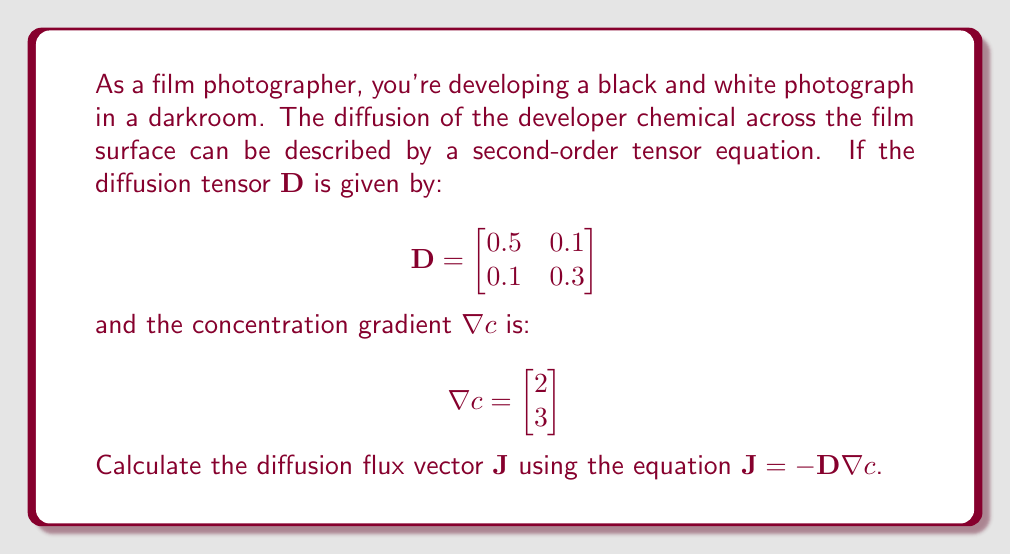Help me with this question. To solve this problem, we need to follow these steps:

1) We are given the diffusion equation: $\mathbf{J} = -\mathbf{D} \nabla c$

2) We have the diffusion tensor $\mathbf{D}$:
   $$\mathbf{D} = \begin{bmatrix}
   0.5 & 0.1 \\
   0.1 & 0.3
   \end{bmatrix}$$

3) And the concentration gradient $\nabla c$:
   $$\nabla c = \begin{bmatrix}
   2 \\
   3
   \end{bmatrix}$$

4) To calculate $\mathbf{J}$, we need to multiply $-\mathbf{D}$ by $\nabla c$:

   $$\mathbf{J} = -\begin{bmatrix}
   0.5 & 0.1 \\
   0.1 & 0.3
   \end{bmatrix} \begin{bmatrix}
   2 \\
   3
   \end{bmatrix}$$

5) Performing the matrix multiplication:

   $$\mathbf{J} = -\begin{bmatrix}
   (0.5 \times 2) + (0.1 \times 3) \\
   (0.1 \times 2) + (0.3 \times 3)
   \end{bmatrix}$$

6) Calculating the components:

   $$\mathbf{J} = -\begin{bmatrix}
   1.0 + 0.3 \\
   0.2 + 0.9
   \end{bmatrix} = -\begin{bmatrix}
   1.3 \\
   1.1
   \end{bmatrix}$$

7) Therefore, the final result is:

   $$\mathbf{J} = \begin{bmatrix}
   -1.3 \\
   -1.1
   \end{bmatrix}$$

This result represents the diffusion flux vector, indicating the direction and magnitude of the chemical diffusion across the film surface.
Answer: $\mathbf{J} = \begin{bmatrix} -1.3 \\ -1.1 \end{bmatrix}$ 